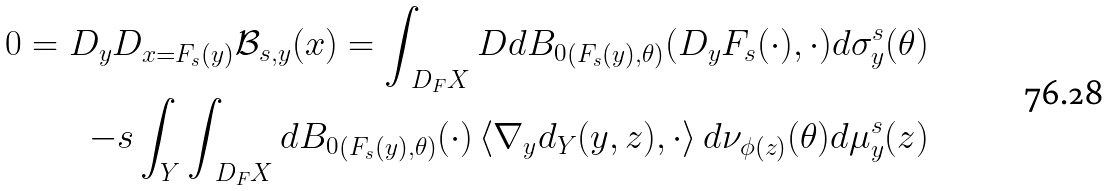Convert formula to latex. <formula><loc_0><loc_0><loc_500><loc_500>0 = D _ { y } D _ { x = F _ { s } ( y ) } \mathcal { B } _ { s , y } ( x ) = \int _ { \ D _ { F } X } D d { B _ { 0 } } _ { ( F _ { s } ( y ) , \theta ) } ( D _ { y } F _ { s } ( \cdot ) , \cdot ) d \sigma ^ { s } _ { y } ( \theta ) \\ - s \int _ { Y } \int _ { \ D _ { F } X } d { B _ { 0 } } _ { ( F _ { s } ( y ) , \theta ) } ( \cdot ) \left < \nabla _ { y } d _ { Y } ( y , z ) , \cdot \right > d \nu _ { \phi ( z ) } ( \theta ) d \mu ^ { s } _ { y } ( z )</formula> 